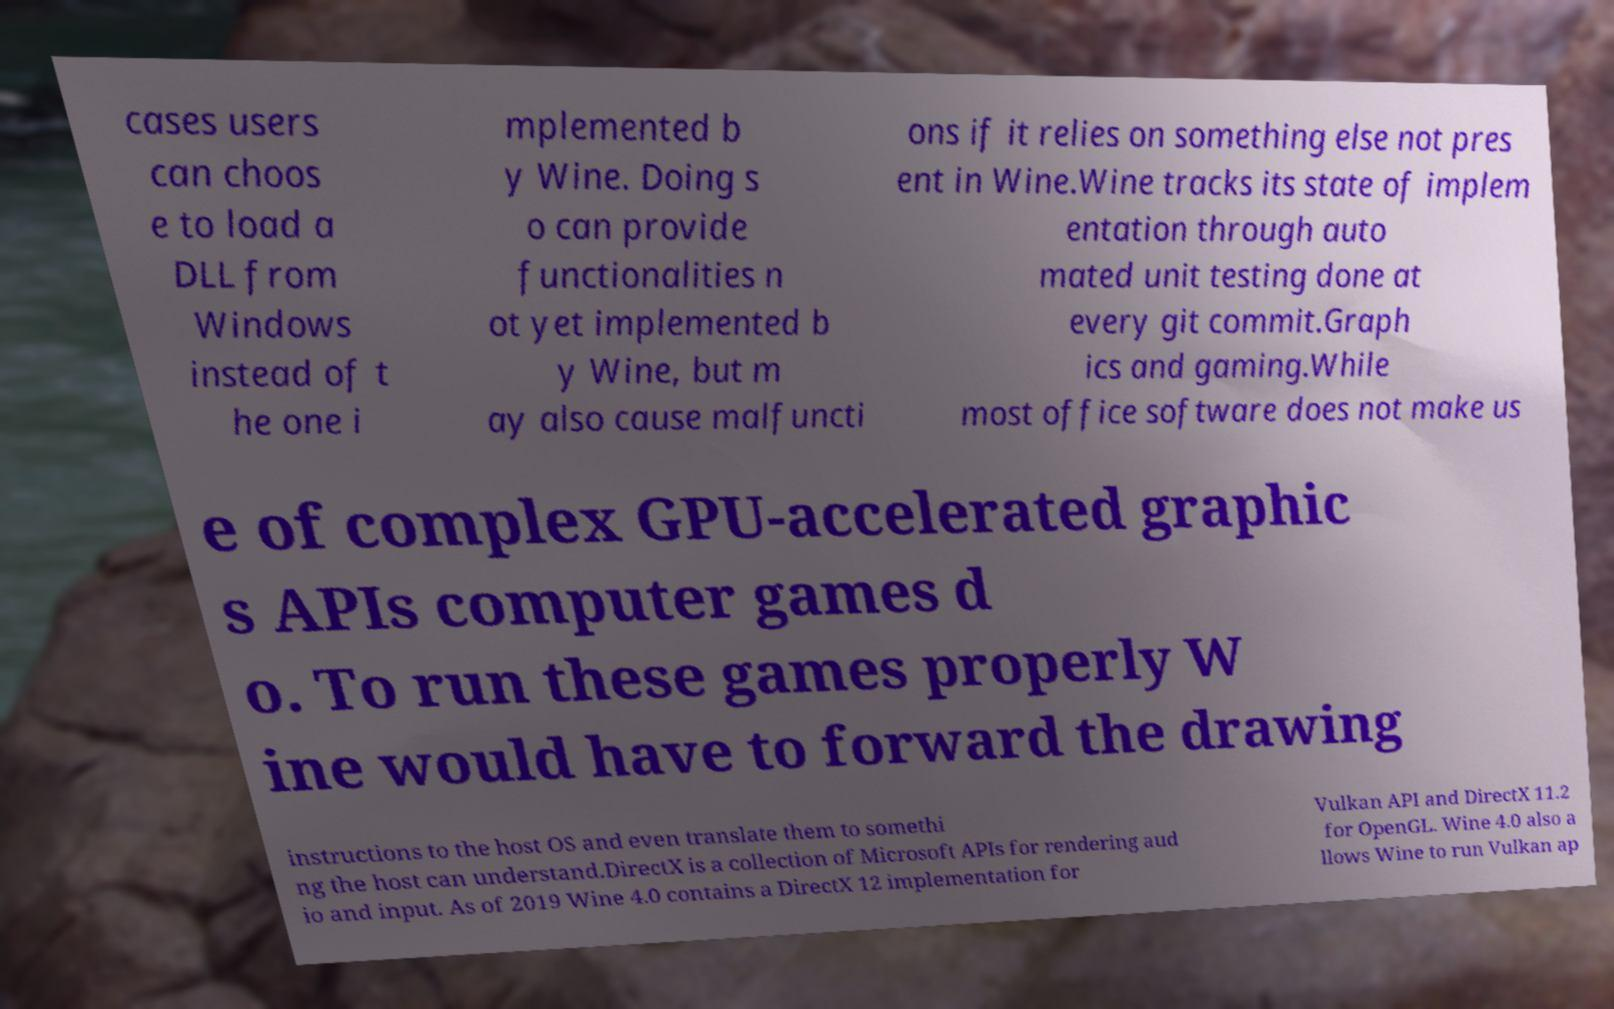Can you read and provide the text displayed in the image?This photo seems to have some interesting text. Can you extract and type it out for me? cases users can choos e to load a DLL from Windows instead of t he one i mplemented b y Wine. Doing s o can provide functionalities n ot yet implemented b y Wine, but m ay also cause malfuncti ons if it relies on something else not pres ent in Wine.Wine tracks its state of implem entation through auto mated unit testing done at every git commit.Graph ics and gaming.While most office software does not make us e of complex GPU-accelerated graphic s APIs computer games d o. To run these games properly W ine would have to forward the drawing instructions to the host OS and even translate them to somethi ng the host can understand.DirectX is a collection of Microsoft APIs for rendering aud io and input. As of 2019 Wine 4.0 contains a DirectX 12 implementation for Vulkan API and DirectX 11.2 for OpenGL. Wine 4.0 also a llows Wine to run Vulkan ap 